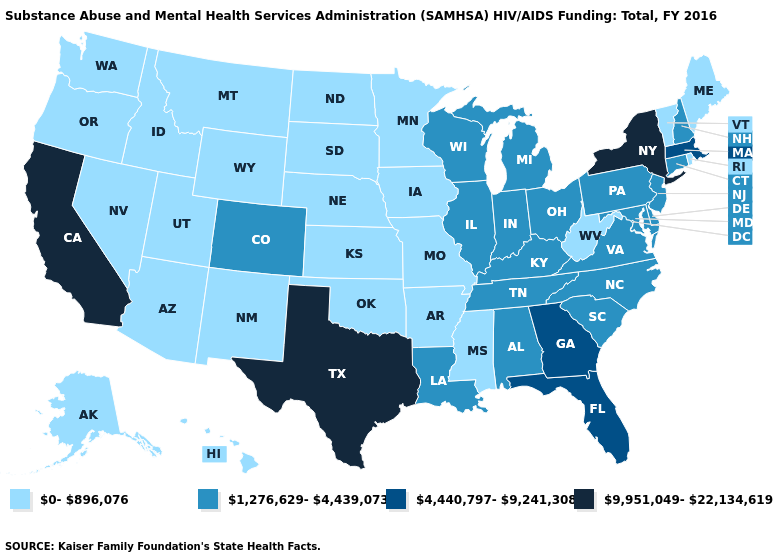Does Maine have a higher value than Wyoming?
Concise answer only. No. What is the value of Maryland?
Answer briefly. 1,276,629-4,439,073. Name the states that have a value in the range 4,440,797-9,241,308?
Write a very short answer. Florida, Georgia, Massachusetts. Name the states that have a value in the range 0-896,076?
Short answer required. Alaska, Arizona, Arkansas, Hawaii, Idaho, Iowa, Kansas, Maine, Minnesota, Mississippi, Missouri, Montana, Nebraska, Nevada, New Mexico, North Dakota, Oklahoma, Oregon, Rhode Island, South Dakota, Utah, Vermont, Washington, West Virginia, Wyoming. Name the states that have a value in the range 4,440,797-9,241,308?
Quick response, please. Florida, Georgia, Massachusetts. Among the states that border Virginia , which have the lowest value?
Quick response, please. West Virginia. Name the states that have a value in the range 0-896,076?
Be succinct. Alaska, Arizona, Arkansas, Hawaii, Idaho, Iowa, Kansas, Maine, Minnesota, Mississippi, Missouri, Montana, Nebraska, Nevada, New Mexico, North Dakota, Oklahoma, Oregon, Rhode Island, South Dakota, Utah, Vermont, Washington, West Virginia, Wyoming. Does the map have missing data?
Give a very brief answer. No. What is the value of Arizona?
Concise answer only. 0-896,076. What is the value of South Carolina?
Quick response, please. 1,276,629-4,439,073. Is the legend a continuous bar?
Give a very brief answer. No. What is the value of Mississippi?
Quick response, please. 0-896,076. Among the states that border Mississippi , which have the highest value?
Answer briefly. Alabama, Louisiana, Tennessee. Name the states that have a value in the range 9,951,049-22,134,619?
Short answer required. California, New York, Texas. Name the states that have a value in the range 1,276,629-4,439,073?
Answer briefly. Alabama, Colorado, Connecticut, Delaware, Illinois, Indiana, Kentucky, Louisiana, Maryland, Michigan, New Hampshire, New Jersey, North Carolina, Ohio, Pennsylvania, South Carolina, Tennessee, Virginia, Wisconsin. 